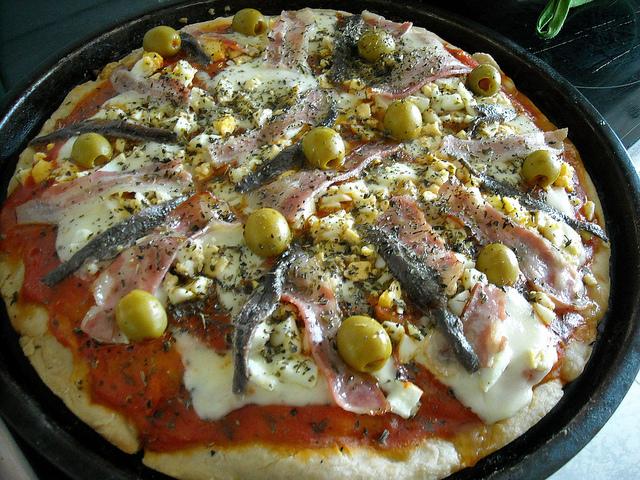Who would eat this?
Short answer required. People. What snack is this?
Concise answer only. Pizza. Are there olives in the photo?
Keep it brief. Yes. 